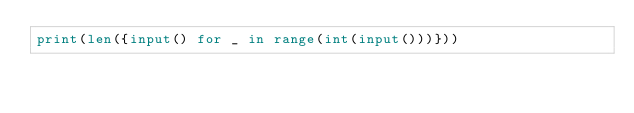<code> <loc_0><loc_0><loc_500><loc_500><_Python_>print(len({input() for _ in range(int(input()))}))
</code> 